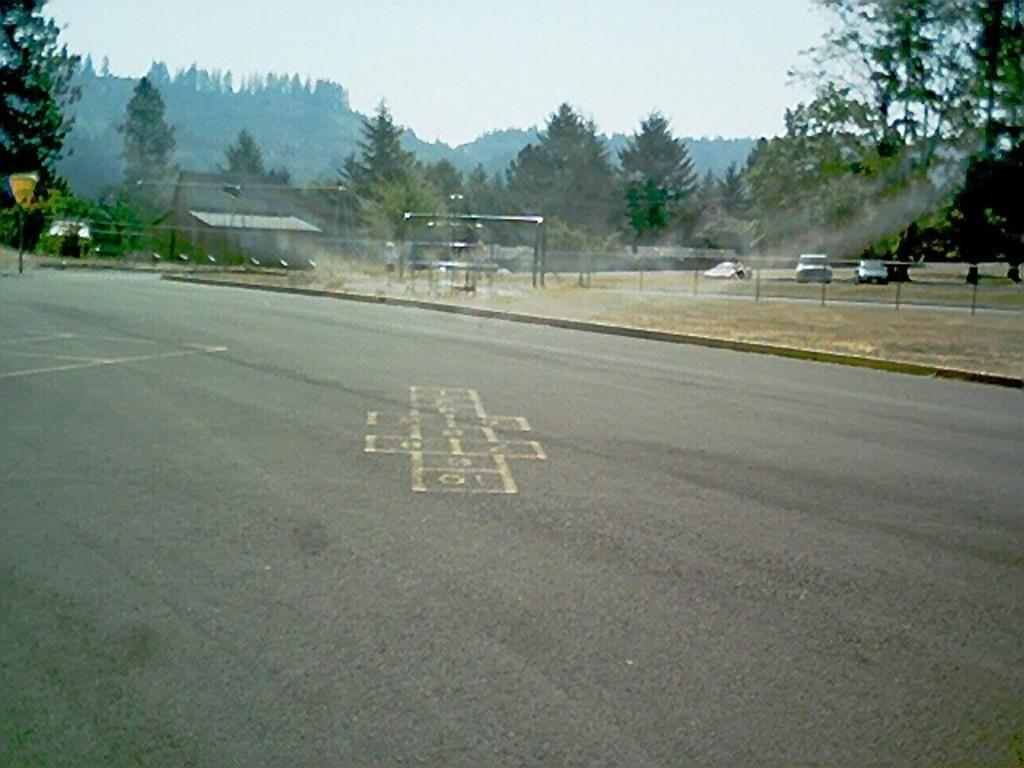What type of pathway is visible in the image? There is a road in the image. What structure can be seen near the road? There is a fence in the image. What are the vehicles in the image used for? The vehicles on the ground in the image are used for transportation. What type of vegetation is present in the image? There are trees in the image. What type of building is visible in the image? There is a house in the image. What is visible in the background of the image? The sky is visible in the background of the image. What type of nut can be seen growing on the trees in the image? There is no nut visible on the trees in the image; only trees are present. What type of street is visible in the image? There is no specific type of street mentioned in the image; it is simply a road. 